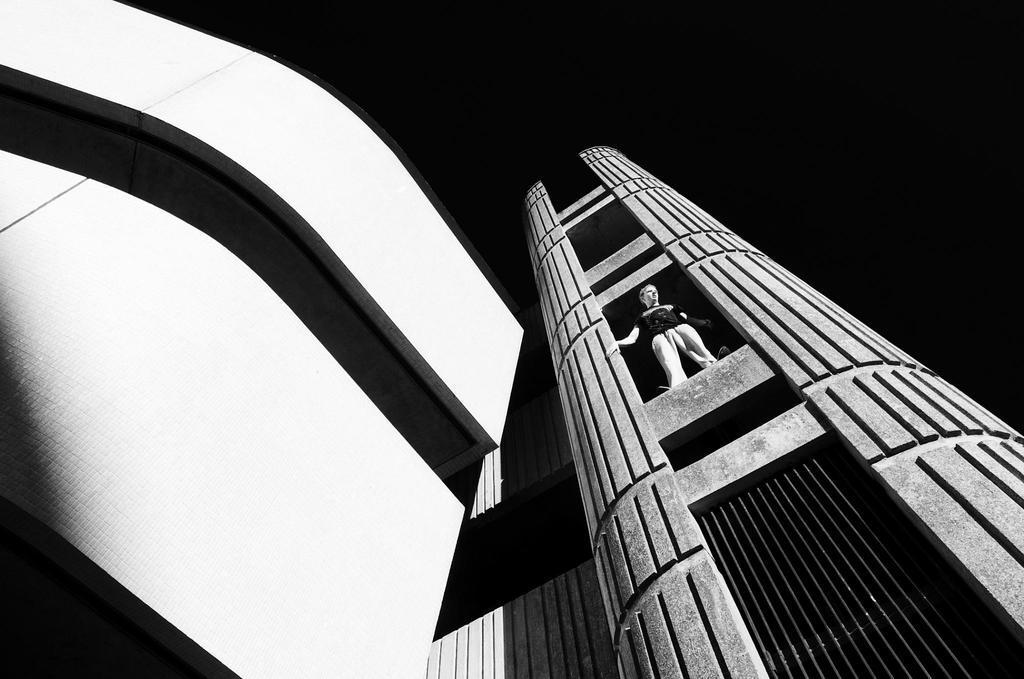In one or two sentences, can you explain what this image depicts? In this picture we can see buildings, there is a person standing in the middle, we can see a dark background. 